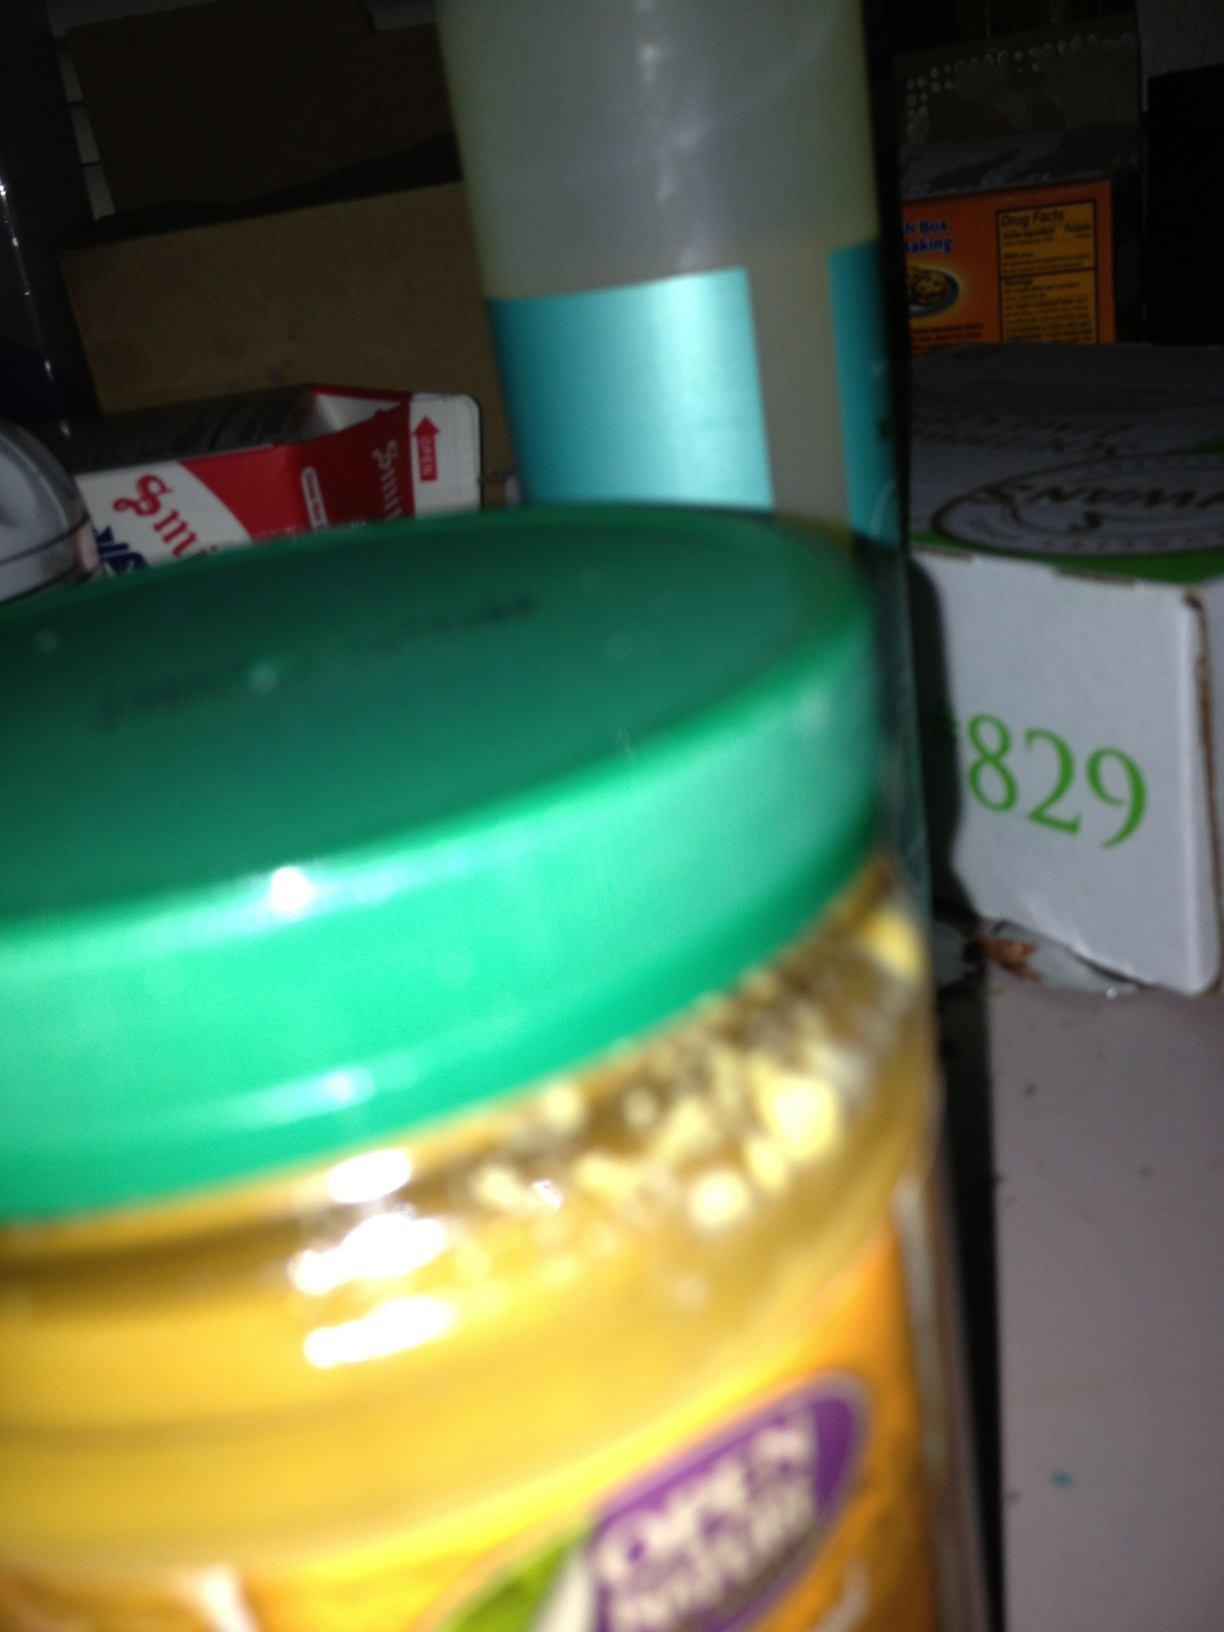Can you describe the items around the jar? Certainly, while the image focus is not sharp, there are several other items alongside the jar. Behind it, there seems to be another tall container with a bluish label that might be a cleaning or personal care product, and further back, there are boxes with visible text which are too blurry to read clearly. These items suggest the picture might have been taken in a storage area or pantry.  Is there anything you can discern about the location from the items present? From the cluttered nature and the variety of objects, it seems like this image was taken in a household storage area or pantry. The presence of food packaging and what could be a household product implies a space where both food and supplies are kept. 